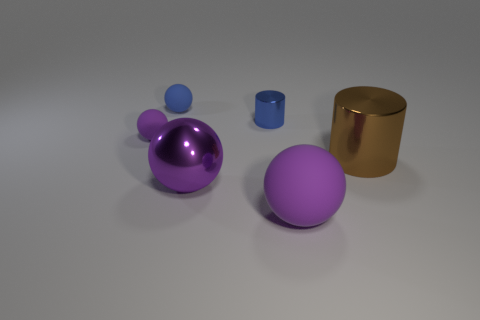What number of things are large cyan rubber cylinders or things?
Give a very brief answer. 6. Is the size of the purple metal sphere the same as the purple rubber object that is in front of the big brown object?
Make the answer very short. Yes. There is a blue matte sphere behind the shiny cylinder on the left side of the purple rubber sphere that is in front of the brown thing; what size is it?
Ensure brevity in your answer.  Small. Is there a big purple ball?
Give a very brief answer. Yes. What material is the sphere that is the same color as the tiny shiny cylinder?
Your response must be concise. Rubber. What number of small metallic cylinders have the same color as the metallic ball?
Your response must be concise. 0. How many things are large purple things that are on the right side of the small blue shiny cylinder or purple rubber spheres that are in front of the big brown thing?
Ensure brevity in your answer.  1. How many big shiny cylinders are on the left side of the tiny matte sphere that is in front of the blue rubber object?
Make the answer very short. 0. What color is the other small object that is the same material as the brown thing?
Your answer should be compact. Blue. Is there another ball that has the same size as the purple metal ball?
Offer a terse response. Yes. 